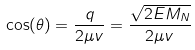Convert formula to latex. <formula><loc_0><loc_0><loc_500><loc_500>\cos ( \theta ) = \frac { q } { 2 \mu v } = \frac { \sqrt { 2 E M _ { N } } } { 2 \mu v }</formula> 